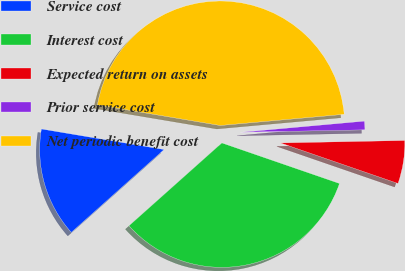<chart> <loc_0><loc_0><loc_500><loc_500><pie_chart><fcel>Service cost<fcel>Interest cost<fcel>Expected return on assets<fcel>Prior service cost<fcel>Net periodic benefit cost<nl><fcel>14.24%<fcel>33.12%<fcel>5.6%<fcel>1.12%<fcel>45.92%<nl></chart> 